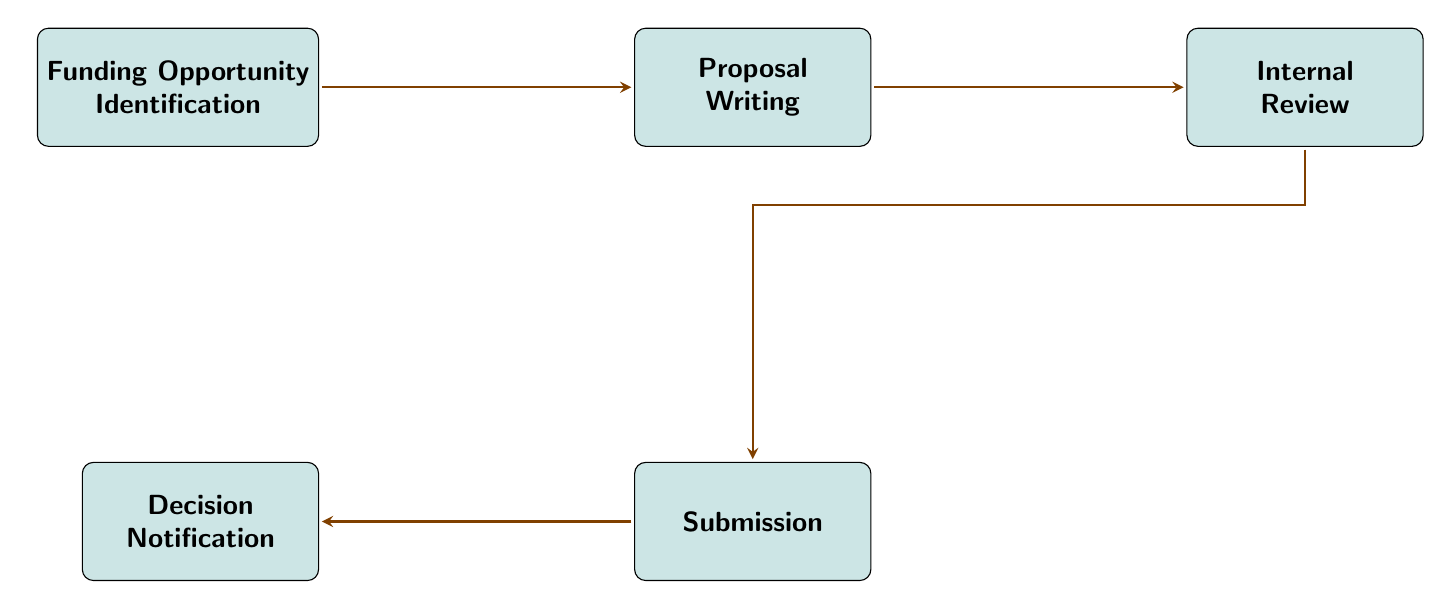What is the first node in the workflow? The diagram begins with the first node labeled "Funding Opportunity Identification," which is the starting point of the funding application process.
Answer: Funding Opportunity Identification How many nodes are in the diagram? The diagram contains a total of five nodes, which include all the stages from identifying funding opportunities to receiving the decision notification.
Answer: 5 What is the final step in the workflow? The last step in the workflow is the "Decision Notification," which is where the applicant receives news about the status of their funding application.
Answer: Decision Notification Which node follows "Proposal Writing"? After "Proposal Writing," the subsequent node is "Internal Review." This indicates that once the proposal is drafted, it should be reviewed internally.
Answer: Internal Review What comes after "Internal Review"? Following "Internal Review," the next step is "Submission," meaning the proposal will be submitted for consideration after the internal feedback has been incorporated.
Answer: Submission Is there any node below "Proposal Writing"? Yes, there is a node below "Proposal Writing" designated as "Submission," illustrating the vertical flow of the process that follows the proposal drafting stage.
Answer: Submission How many edges connect the nodes in the workflow? There are a total of four edges connecting the five nodes, as each node, except for the last one, has a directed flow to the following node in the sequence.
Answer: 4 What is the relationship between "Funding Opportunity Identification" and "Decision Notification"? The relationship between these two nodes is sequential; "Funding Opportunity Identification" initiates the workflow, which ultimately leads to the "Decision Notification" after all other steps have been completed.
Answer: Sequential Which nodes have a horizontal relationship in the diagram? The nodes that have a horizontal relationship are "Funding Opportunity Identification" and "Proposal Writing," as well as "Proposal Writing" and "Internal Review," illustrating the linear progression in the application process.
Answer: Funding Opportunity Identification, Proposal Writing; Proposal Writing, Internal Review 